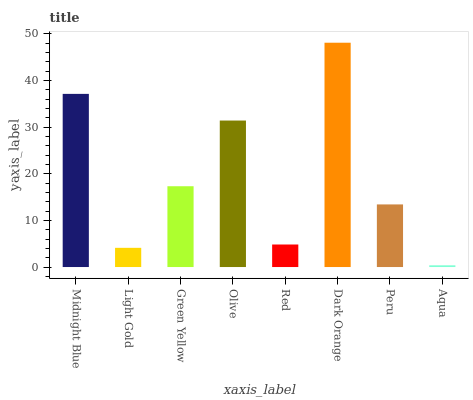Is Aqua the minimum?
Answer yes or no. Yes. Is Dark Orange the maximum?
Answer yes or no. Yes. Is Light Gold the minimum?
Answer yes or no. No. Is Light Gold the maximum?
Answer yes or no. No. Is Midnight Blue greater than Light Gold?
Answer yes or no. Yes. Is Light Gold less than Midnight Blue?
Answer yes or no. Yes. Is Light Gold greater than Midnight Blue?
Answer yes or no. No. Is Midnight Blue less than Light Gold?
Answer yes or no. No. Is Green Yellow the high median?
Answer yes or no. Yes. Is Peru the low median?
Answer yes or no. Yes. Is Aqua the high median?
Answer yes or no. No. Is Green Yellow the low median?
Answer yes or no. No. 